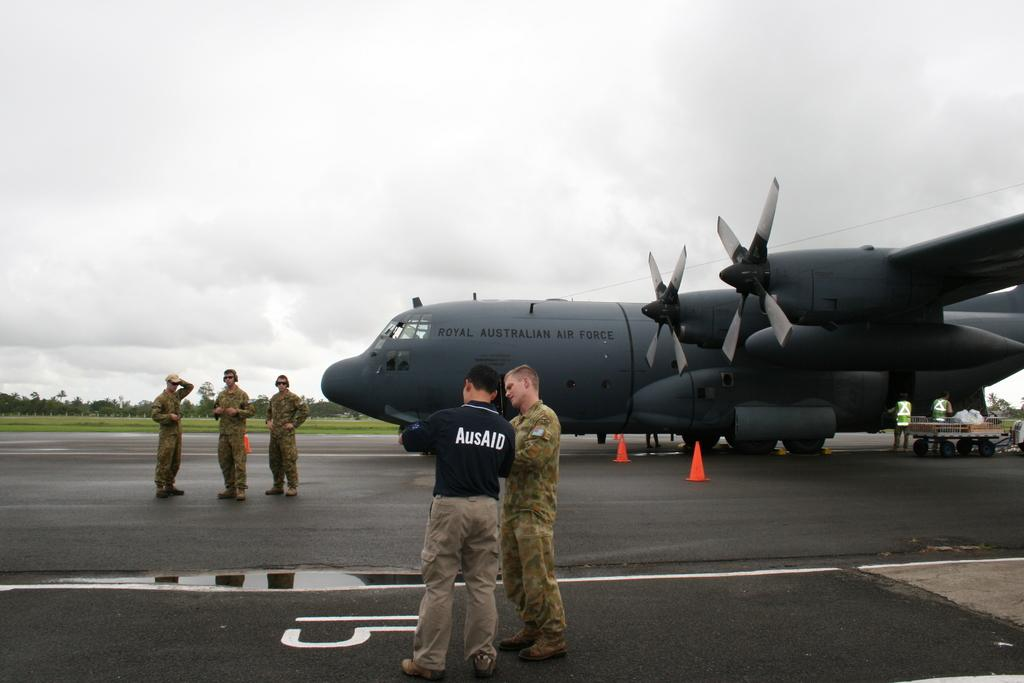<image>
Describe the image concisely. Two men, one wearing a shirt that says AusAID, are talking in front of a very large plane. 